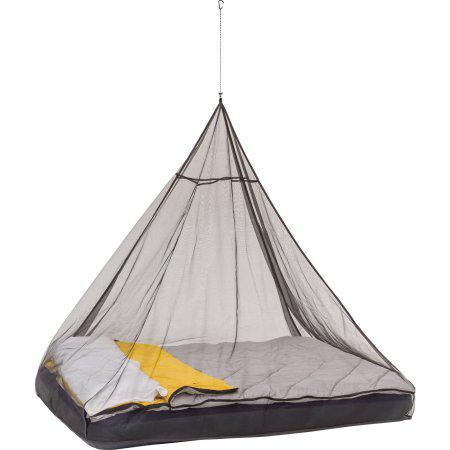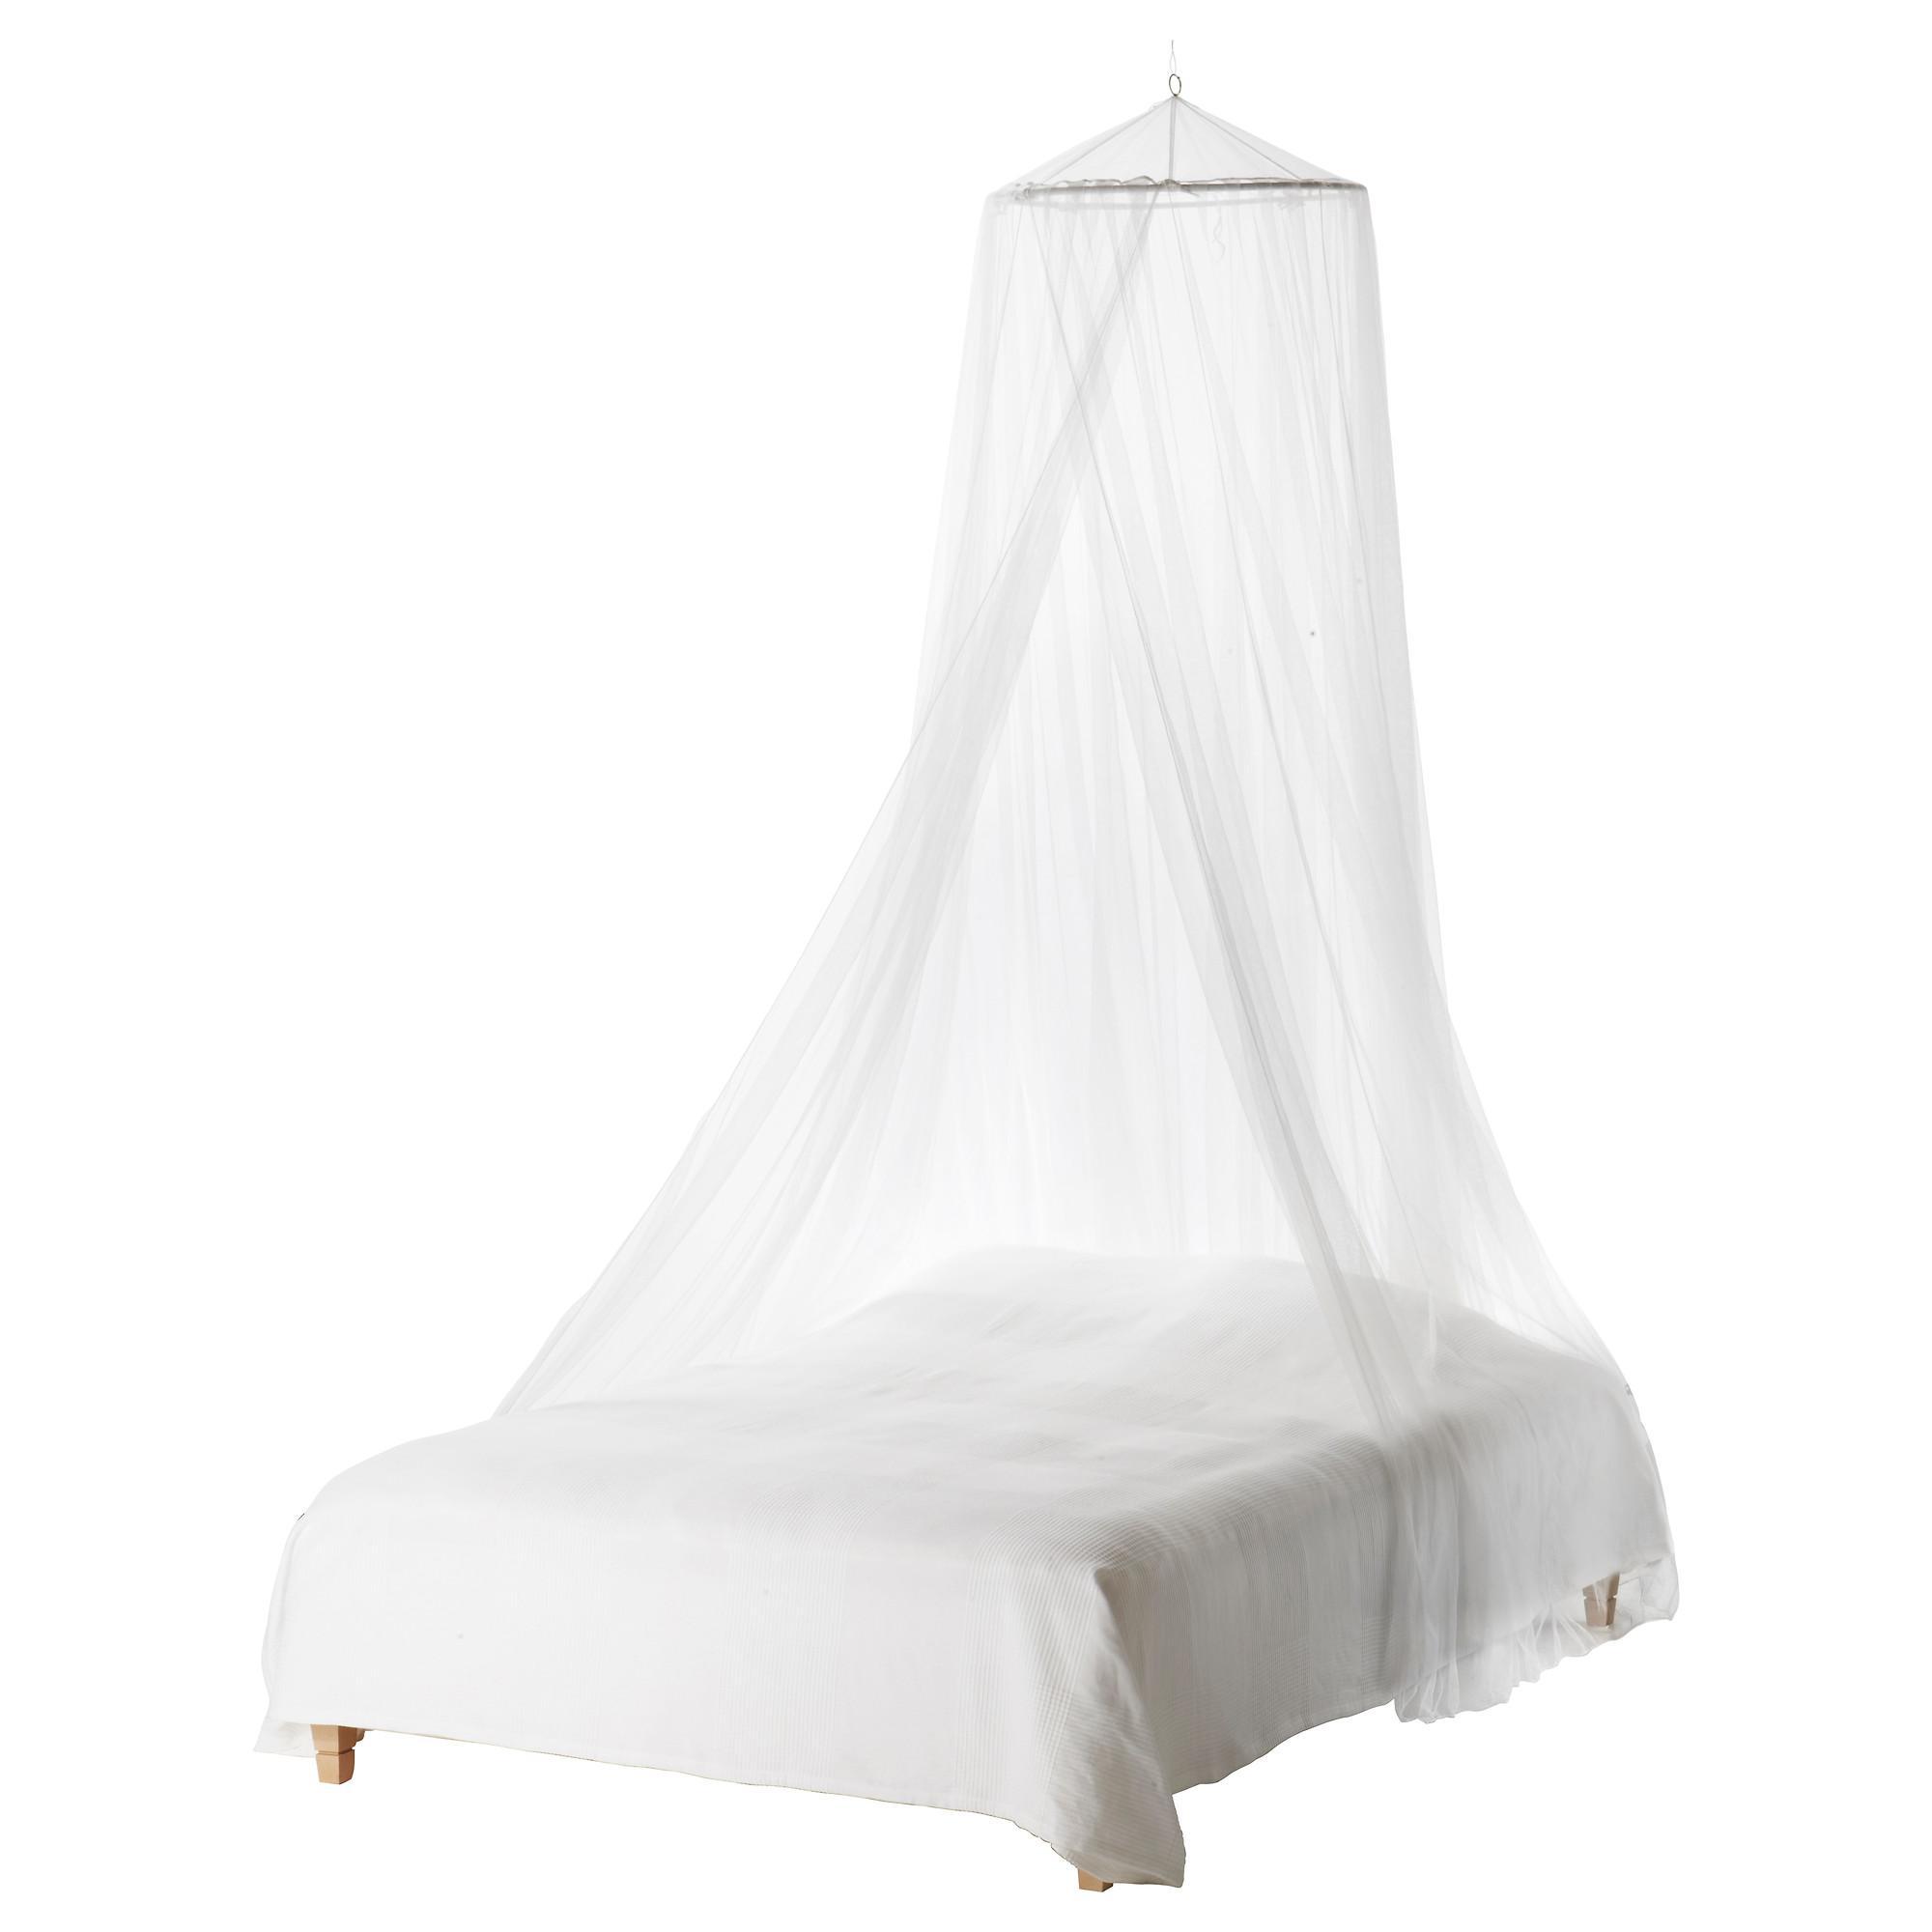The first image is the image on the left, the second image is the image on the right. Examine the images to the left and right. Is the description "There are two canopies with at least one mostly square one." accurate? Answer yes or no. No. 